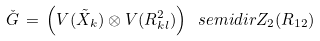<formula> <loc_0><loc_0><loc_500><loc_500>\check { G } \, = \, \left ( V ( \tilde { X } _ { k } ) \otimes V ( R _ { k l } ^ { 2 } ) \right ) \ s e m i d i r Z _ { 2 } ( R _ { 1 2 } )</formula> 